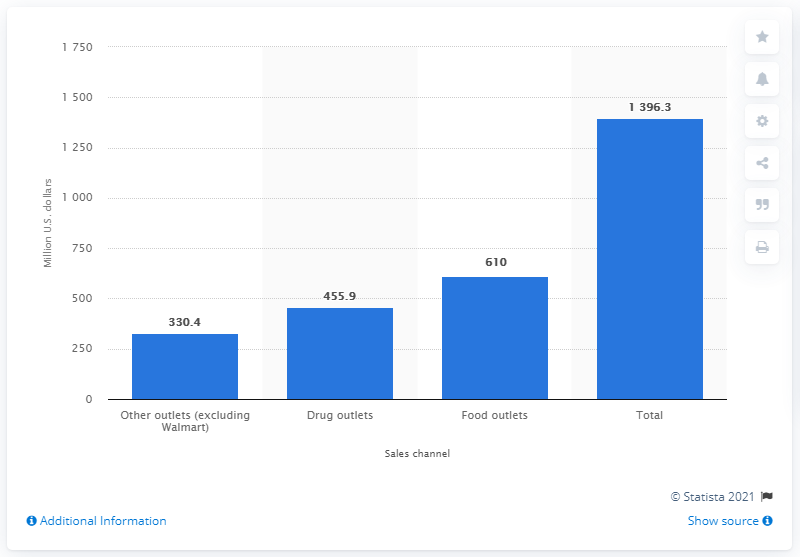Identify some key points in this picture. In 2011 and 2012, a total of 455.9 dollars was spent on shampoo through drug outlets. The total U.S. shampoo sales in 2011/2012 was 1,396.3. 